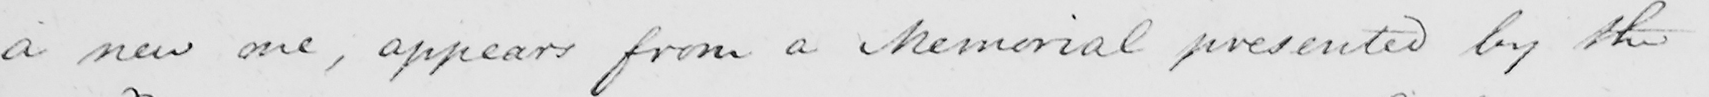Can you tell me what this handwritten text says? a new one , appears from a Memorial presented by the 